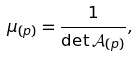Convert formula to latex. <formula><loc_0><loc_0><loc_500><loc_500>\mu _ { ( p ) } = \frac { 1 } { \det \mathcal { A } _ { ( p ) } } ,</formula> 